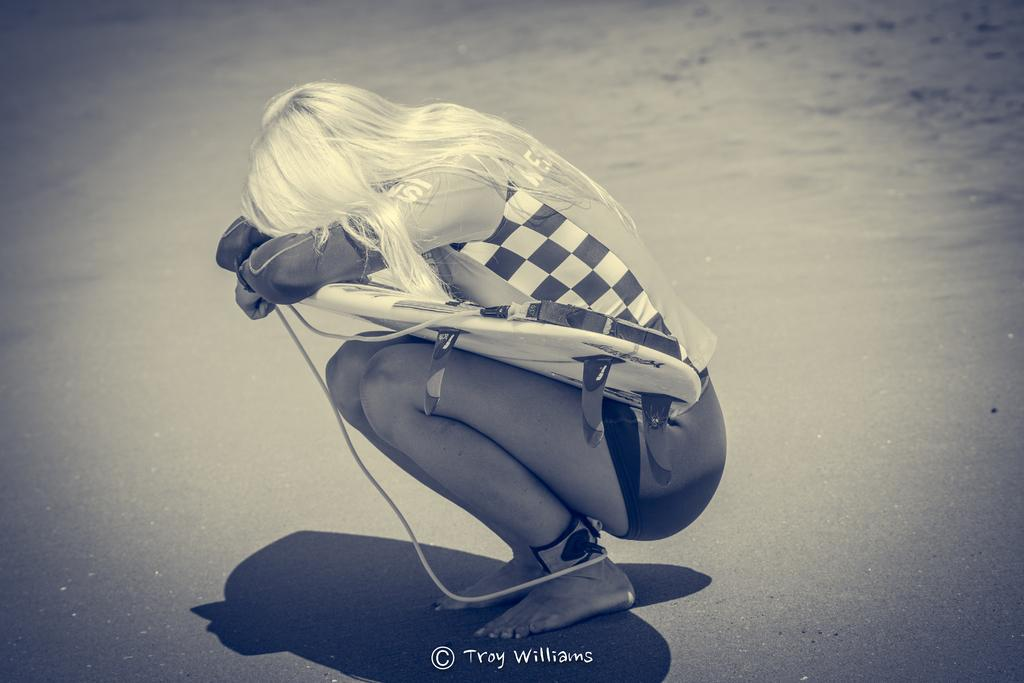What is the main subject of the image? There is a woman in the image. What is the woman doing in the image? The woman is sitting and covering her face with her hands or arms. What object is associated with the woman in the image? There is a surfboard in the image. What can be seen in the background of the image? There is sand visible in the background of the image. What is a notable feature of the woman's appearance? The woman has white hair. What type of treatment does the woman receive from her father in the image? There is no father present in the image, and no treatment is being administered. 